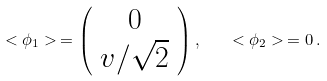<formula> <loc_0><loc_0><loc_500><loc_500>< \phi _ { 1 } > \, = \left ( \begin{array} { c } 0 \\ { v / \sqrt { 2 } } \end{array} \right ) , \quad < \phi _ { 2 } > \, = 0 \, .</formula> 